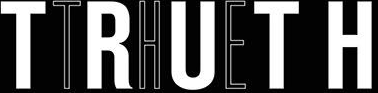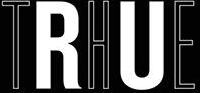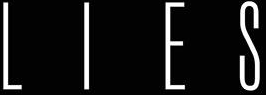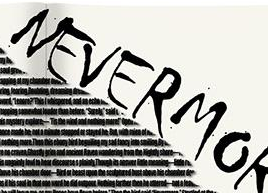Transcribe the words shown in these images in order, separated by a semicolon. TRUTH; THE; LIES; NEVERMO 